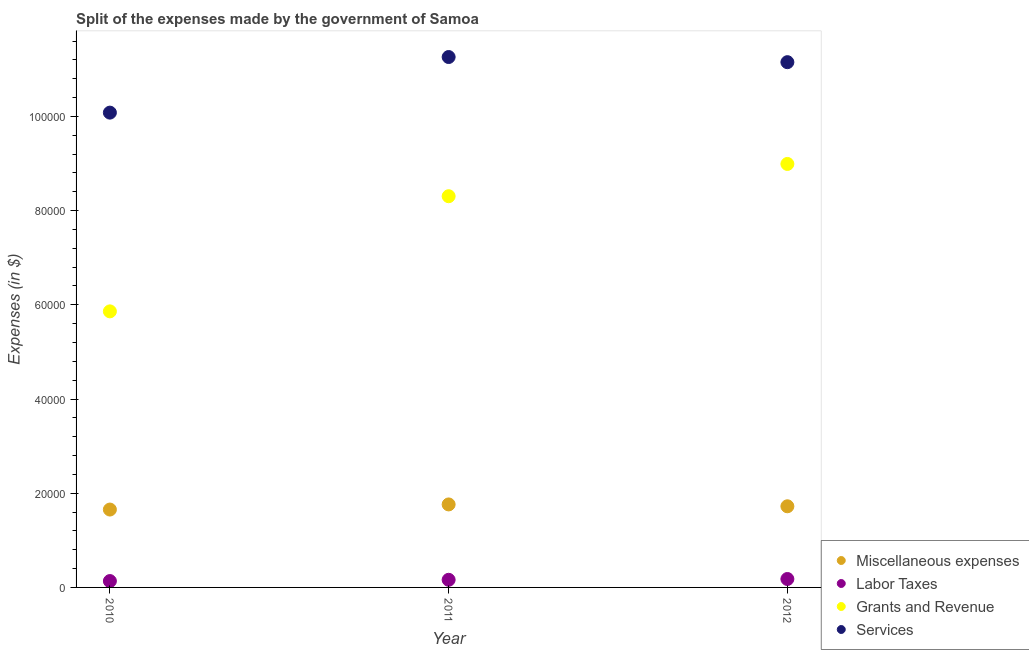How many different coloured dotlines are there?
Offer a very short reply. 4. Is the number of dotlines equal to the number of legend labels?
Your answer should be compact. Yes. What is the amount spent on miscellaneous expenses in 2010?
Provide a short and direct response. 1.65e+04. Across all years, what is the maximum amount spent on grants and revenue?
Provide a succinct answer. 8.99e+04. Across all years, what is the minimum amount spent on services?
Offer a terse response. 1.01e+05. In which year was the amount spent on miscellaneous expenses maximum?
Keep it short and to the point. 2011. In which year was the amount spent on grants and revenue minimum?
Your answer should be compact. 2010. What is the total amount spent on labor taxes in the graph?
Provide a short and direct response. 4758.23. What is the difference between the amount spent on miscellaneous expenses in 2011 and that in 2012?
Ensure brevity in your answer.  394.36. What is the difference between the amount spent on grants and revenue in 2011 and the amount spent on miscellaneous expenses in 2012?
Your response must be concise. 6.58e+04. What is the average amount spent on labor taxes per year?
Ensure brevity in your answer.  1586.08. In the year 2010, what is the difference between the amount spent on services and amount spent on labor taxes?
Give a very brief answer. 9.95e+04. What is the ratio of the amount spent on grants and revenue in 2010 to that in 2012?
Your answer should be compact. 0.65. Is the difference between the amount spent on labor taxes in 2011 and 2012 greater than the difference between the amount spent on grants and revenue in 2011 and 2012?
Your answer should be very brief. Yes. What is the difference between the highest and the second highest amount spent on miscellaneous expenses?
Offer a terse response. 394.36. What is the difference between the highest and the lowest amount spent on services?
Keep it short and to the point. 1.18e+04. In how many years, is the amount spent on services greater than the average amount spent on services taken over all years?
Ensure brevity in your answer.  2. Is it the case that in every year, the sum of the amount spent on miscellaneous expenses and amount spent on services is greater than the sum of amount spent on grants and revenue and amount spent on labor taxes?
Your answer should be compact. No. Does the amount spent on miscellaneous expenses monotonically increase over the years?
Offer a terse response. No. Is the amount spent on labor taxes strictly less than the amount spent on grants and revenue over the years?
Make the answer very short. Yes. How many dotlines are there?
Offer a terse response. 4. Are the values on the major ticks of Y-axis written in scientific E-notation?
Give a very brief answer. No. Does the graph contain grids?
Your answer should be compact. No. Where does the legend appear in the graph?
Make the answer very short. Bottom right. How many legend labels are there?
Offer a very short reply. 4. How are the legend labels stacked?
Ensure brevity in your answer.  Vertical. What is the title of the graph?
Offer a very short reply. Split of the expenses made by the government of Samoa. What is the label or title of the X-axis?
Ensure brevity in your answer.  Year. What is the label or title of the Y-axis?
Make the answer very short. Expenses (in $). What is the Expenses (in $) of Miscellaneous expenses in 2010?
Give a very brief answer. 1.65e+04. What is the Expenses (in $) of Labor Taxes in 2010?
Give a very brief answer. 1351.1. What is the Expenses (in $) of Grants and Revenue in 2010?
Provide a succinct answer. 5.86e+04. What is the Expenses (in $) in Services in 2010?
Keep it short and to the point. 1.01e+05. What is the Expenses (in $) of Miscellaneous expenses in 2011?
Your answer should be compact. 1.76e+04. What is the Expenses (in $) of Labor Taxes in 2011?
Offer a terse response. 1618.63. What is the Expenses (in $) of Grants and Revenue in 2011?
Provide a succinct answer. 8.31e+04. What is the Expenses (in $) of Services in 2011?
Ensure brevity in your answer.  1.13e+05. What is the Expenses (in $) of Miscellaneous expenses in 2012?
Offer a terse response. 1.72e+04. What is the Expenses (in $) in Labor Taxes in 2012?
Ensure brevity in your answer.  1788.5. What is the Expenses (in $) in Grants and Revenue in 2012?
Keep it short and to the point. 8.99e+04. What is the Expenses (in $) in Services in 2012?
Offer a terse response. 1.12e+05. Across all years, what is the maximum Expenses (in $) in Miscellaneous expenses?
Provide a succinct answer. 1.76e+04. Across all years, what is the maximum Expenses (in $) of Labor Taxes?
Offer a terse response. 1788.5. Across all years, what is the maximum Expenses (in $) in Grants and Revenue?
Ensure brevity in your answer.  8.99e+04. Across all years, what is the maximum Expenses (in $) in Services?
Provide a short and direct response. 1.13e+05. Across all years, what is the minimum Expenses (in $) of Miscellaneous expenses?
Your answer should be very brief. 1.65e+04. Across all years, what is the minimum Expenses (in $) in Labor Taxes?
Offer a terse response. 1351.1. Across all years, what is the minimum Expenses (in $) of Grants and Revenue?
Your answer should be very brief. 5.86e+04. Across all years, what is the minimum Expenses (in $) in Services?
Ensure brevity in your answer.  1.01e+05. What is the total Expenses (in $) of Miscellaneous expenses in the graph?
Give a very brief answer. 5.14e+04. What is the total Expenses (in $) in Labor Taxes in the graph?
Your response must be concise. 4758.23. What is the total Expenses (in $) of Grants and Revenue in the graph?
Your answer should be very brief. 2.32e+05. What is the total Expenses (in $) in Services in the graph?
Offer a very short reply. 3.25e+05. What is the difference between the Expenses (in $) of Miscellaneous expenses in 2010 and that in 2011?
Offer a terse response. -1087.75. What is the difference between the Expenses (in $) of Labor Taxes in 2010 and that in 2011?
Keep it short and to the point. -267.53. What is the difference between the Expenses (in $) of Grants and Revenue in 2010 and that in 2011?
Your response must be concise. -2.44e+04. What is the difference between the Expenses (in $) in Services in 2010 and that in 2011?
Offer a terse response. -1.18e+04. What is the difference between the Expenses (in $) in Miscellaneous expenses in 2010 and that in 2012?
Provide a succinct answer. -693.38. What is the difference between the Expenses (in $) in Labor Taxes in 2010 and that in 2012?
Provide a succinct answer. -437.4. What is the difference between the Expenses (in $) in Grants and Revenue in 2010 and that in 2012?
Your answer should be compact. -3.13e+04. What is the difference between the Expenses (in $) of Services in 2010 and that in 2012?
Keep it short and to the point. -1.07e+04. What is the difference between the Expenses (in $) of Miscellaneous expenses in 2011 and that in 2012?
Your answer should be compact. 394.36. What is the difference between the Expenses (in $) of Labor Taxes in 2011 and that in 2012?
Offer a very short reply. -169.87. What is the difference between the Expenses (in $) in Grants and Revenue in 2011 and that in 2012?
Make the answer very short. -6851.45. What is the difference between the Expenses (in $) of Services in 2011 and that in 2012?
Your response must be concise. 1092.45. What is the difference between the Expenses (in $) in Miscellaneous expenses in 2010 and the Expenses (in $) in Labor Taxes in 2011?
Offer a terse response. 1.49e+04. What is the difference between the Expenses (in $) of Miscellaneous expenses in 2010 and the Expenses (in $) of Grants and Revenue in 2011?
Give a very brief answer. -6.65e+04. What is the difference between the Expenses (in $) in Miscellaneous expenses in 2010 and the Expenses (in $) in Services in 2011?
Offer a terse response. -9.61e+04. What is the difference between the Expenses (in $) in Labor Taxes in 2010 and the Expenses (in $) in Grants and Revenue in 2011?
Provide a succinct answer. -8.17e+04. What is the difference between the Expenses (in $) in Labor Taxes in 2010 and the Expenses (in $) in Services in 2011?
Ensure brevity in your answer.  -1.11e+05. What is the difference between the Expenses (in $) of Grants and Revenue in 2010 and the Expenses (in $) of Services in 2011?
Provide a succinct answer. -5.40e+04. What is the difference between the Expenses (in $) in Miscellaneous expenses in 2010 and the Expenses (in $) in Labor Taxes in 2012?
Give a very brief answer. 1.47e+04. What is the difference between the Expenses (in $) of Miscellaneous expenses in 2010 and the Expenses (in $) of Grants and Revenue in 2012?
Make the answer very short. -7.34e+04. What is the difference between the Expenses (in $) of Miscellaneous expenses in 2010 and the Expenses (in $) of Services in 2012?
Provide a succinct answer. -9.50e+04. What is the difference between the Expenses (in $) of Labor Taxes in 2010 and the Expenses (in $) of Grants and Revenue in 2012?
Ensure brevity in your answer.  -8.86e+04. What is the difference between the Expenses (in $) in Labor Taxes in 2010 and the Expenses (in $) in Services in 2012?
Your answer should be compact. -1.10e+05. What is the difference between the Expenses (in $) in Grants and Revenue in 2010 and the Expenses (in $) in Services in 2012?
Your answer should be compact. -5.29e+04. What is the difference between the Expenses (in $) of Miscellaneous expenses in 2011 and the Expenses (in $) of Labor Taxes in 2012?
Provide a succinct answer. 1.58e+04. What is the difference between the Expenses (in $) in Miscellaneous expenses in 2011 and the Expenses (in $) in Grants and Revenue in 2012?
Your response must be concise. -7.23e+04. What is the difference between the Expenses (in $) of Miscellaneous expenses in 2011 and the Expenses (in $) of Services in 2012?
Provide a short and direct response. -9.39e+04. What is the difference between the Expenses (in $) of Labor Taxes in 2011 and the Expenses (in $) of Grants and Revenue in 2012?
Your answer should be very brief. -8.83e+04. What is the difference between the Expenses (in $) of Labor Taxes in 2011 and the Expenses (in $) of Services in 2012?
Your answer should be very brief. -1.10e+05. What is the difference between the Expenses (in $) in Grants and Revenue in 2011 and the Expenses (in $) in Services in 2012?
Provide a short and direct response. -2.85e+04. What is the average Expenses (in $) of Miscellaneous expenses per year?
Provide a succinct answer. 1.71e+04. What is the average Expenses (in $) in Labor Taxes per year?
Your answer should be very brief. 1586.08. What is the average Expenses (in $) of Grants and Revenue per year?
Your response must be concise. 7.72e+04. What is the average Expenses (in $) in Services per year?
Offer a terse response. 1.08e+05. In the year 2010, what is the difference between the Expenses (in $) of Miscellaneous expenses and Expenses (in $) of Labor Taxes?
Your answer should be compact. 1.52e+04. In the year 2010, what is the difference between the Expenses (in $) of Miscellaneous expenses and Expenses (in $) of Grants and Revenue?
Provide a succinct answer. -4.21e+04. In the year 2010, what is the difference between the Expenses (in $) in Miscellaneous expenses and Expenses (in $) in Services?
Keep it short and to the point. -8.43e+04. In the year 2010, what is the difference between the Expenses (in $) in Labor Taxes and Expenses (in $) in Grants and Revenue?
Make the answer very short. -5.73e+04. In the year 2010, what is the difference between the Expenses (in $) of Labor Taxes and Expenses (in $) of Services?
Make the answer very short. -9.95e+04. In the year 2010, what is the difference between the Expenses (in $) in Grants and Revenue and Expenses (in $) in Services?
Your answer should be compact. -4.22e+04. In the year 2011, what is the difference between the Expenses (in $) of Miscellaneous expenses and Expenses (in $) of Labor Taxes?
Keep it short and to the point. 1.60e+04. In the year 2011, what is the difference between the Expenses (in $) in Miscellaneous expenses and Expenses (in $) in Grants and Revenue?
Offer a terse response. -6.54e+04. In the year 2011, what is the difference between the Expenses (in $) in Miscellaneous expenses and Expenses (in $) in Services?
Make the answer very short. -9.50e+04. In the year 2011, what is the difference between the Expenses (in $) in Labor Taxes and Expenses (in $) in Grants and Revenue?
Your response must be concise. -8.14e+04. In the year 2011, what is the difference between the Expenses (in $) of Labor Taxes and Expenses (in $) of Services?
Your answer should be compact. -1.11e+05. In the year 2011, what is the difference between the Expenses (in $) of Grants and Revenue and Expenses (in $) of Services?
Keep it short and to the point. -2.96e+04. In the year 2012, what is the difference between the Expenses (in $) in Miscellaneous expenses and Expenses (in $) in Labor Taxes?
Your answer should be compact. 1.54e+04. In the year 2012, what is the difference between the Expenses (in $) of Miscellaneous expenses and Expenses (in $) of Grants and Revenue?
Provide a succinct answer. -7.27e+04. In the year 2012, what is the difference between the Expenses (in $) of Miscellaneous expenses and Expenses (in $) of Services?
Provide a short and direct response. -9.43e+04. In the year 2012, what is the difference between the Expenses (in $) in Labor Taxes and Expenses (in $) in Grants and Revenue?
Ensure brevity in your answer.  -8.81e+04. In the year 2012, what is the difference between the Expenses (in $) of Labor Taxes and Expenses (in $) of Services?
Your answer should be very brief. -1.10e+05. In the year 2012, what is the difference between the Expenses (in $) of Grants and Revenue and Expenses (in $) of Services?
Provide a short and direct response. -2.16e+04. What is the ratio of the Expenses (in $) of Miscellaneous expenses in 2010 to that in 2011?
Your response must be concise. 0.94. What is the ratio of the Expenses (in $) in Labor Taxes in 2010 to that in 2011?
Your answer should be compact. 0.83. What is the ratio of the Expenses (in $) of Grants and Revenue in 2010 to that in 2011?
Ensure brevity in your answer.  0.71. What is the ratio of the Expenses (in $) of Services in 2010 to that in 2011?
Offer a terse response. 0.9. What is the ratio of the Expenses (in $) in Miscellaneous expenses in 2010 to that in 2012?
Provide a short and direct response. 0.96. What is the ratio of the Expenses (in $) of Labor Taxes in 2010 to that in 2012?
Ensure brevity in your answer.  0.76. What is the ratio of the Expenses (in $) in Grants and Revenue in 2010 to that in 2012?
Your answer should be compact. 0.65. What is the ratio of the Expenses (in $) in Services in 2010 to that in 2012?
Offer a terse response. 0.9. What is the ratio of the Expenses (in $) in Miscellaneous expenses in 2011 to that in 2012?
Your answer should be very brief. 1.02. What is the ratio of the Expenses (in $) in Labor Taxes in 2011 to that in 2012?
Offer a terse response. 0.91. What is the ratio of the Expenses (in $) in Grants and Revenue in 2011 to that in 2012?
Give a very brief answer. 0.92. What is the ratio of the Expenses (in $) in Services in 2011 to that in 2012?
Give a very brief answer. 1.01. What is the difference between the highest and the second highest Expenses (in $) of Miscellaneous expenses?
Make the answer very short. 394.36. What is the difference between the highest and the second highest Expenses (in $) in Labor Taxes?
Your response must be concise. 169.87. What is the difference between the highest and the second highest Expenses (in $) in Grants and Revenue?
Provide a short and direct response. 6851.45. What is the difference between the highest and the second highest Expenses (in $) of Services?
Your response must be concise. 1092.45. What is the difference between the highest and the lowest Expenses (in $) of Miscellaneous expenses?
Provide a short and direct response. 1087.75. What is the difference between the highest and the lowest Expenses (in $) in Labor Taxes?
Offer a very short reply. 437.4. What is the difference between the highest and the lowest Expenses (in $) in Grants and Revenue?
Give a very brief answer. 3.13e+04. What is the difference between the highest and the lowest Expenses (in $) of Services?
Give a very brief answer. 1.18e+04. 